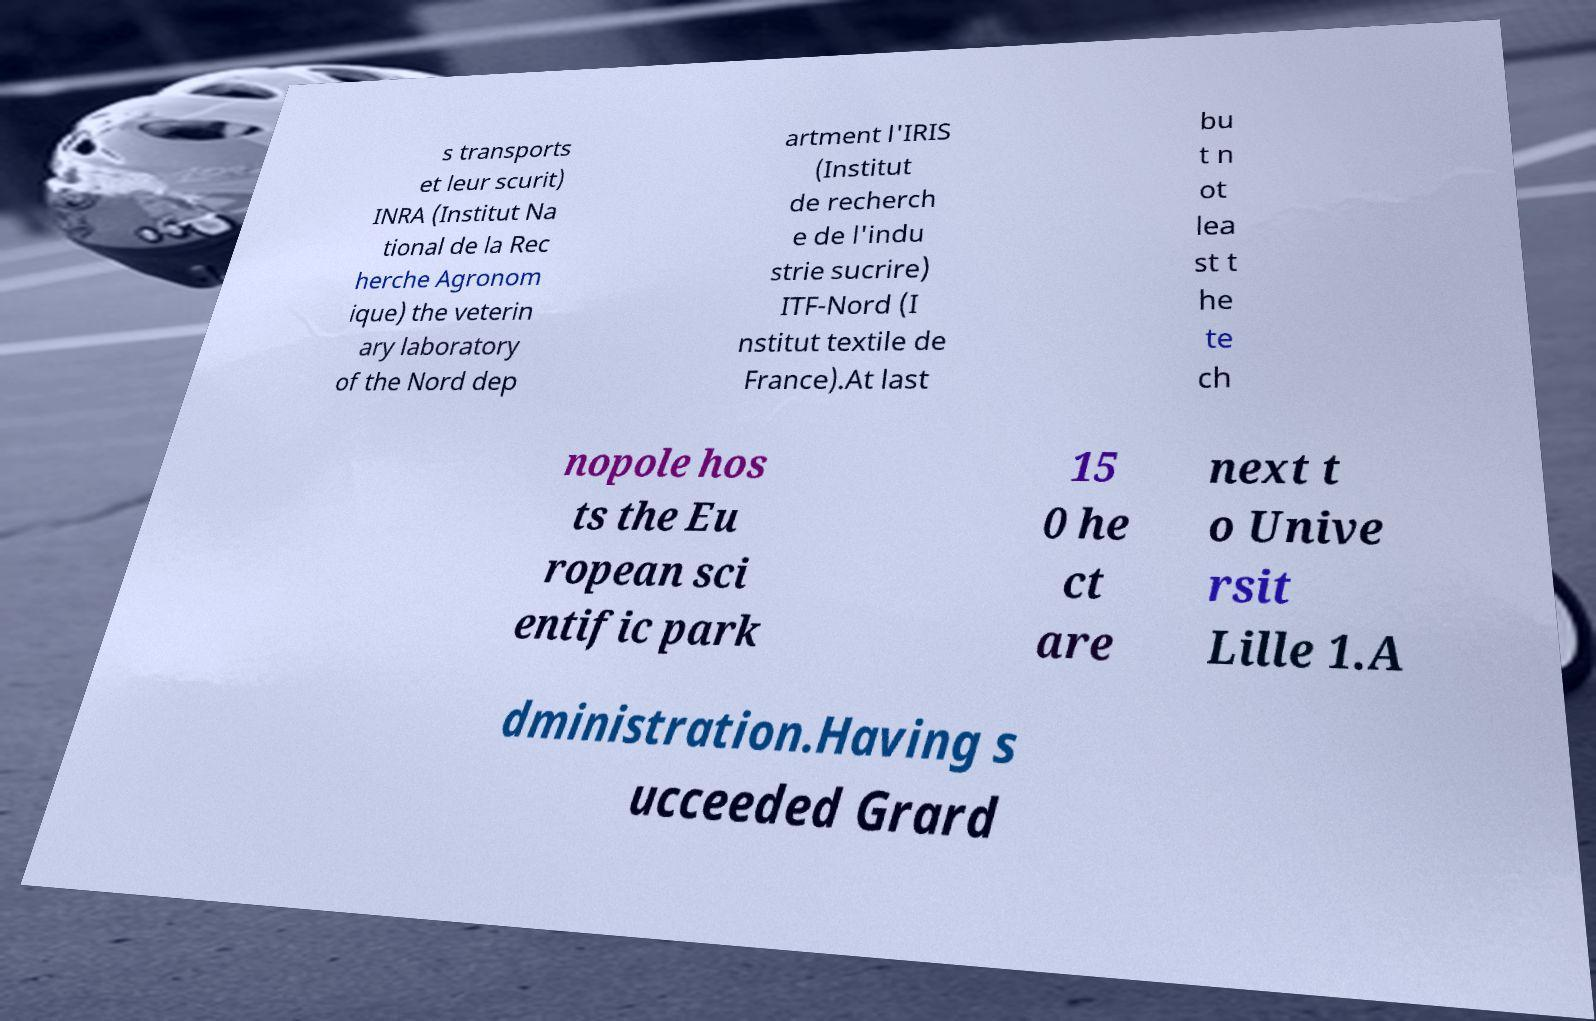Please read and relay the text visible in this image. What does it say? s transports et leur scurit) INRA (Institut Na tional de la Rec herche Agronom ique) the veterin ary laboratory of the Nord dep artment l'IRIS (Institut de recherch e de l'indu strie sucrire) ITF-Nord (I nstitut textile de France).At last bu t n ot lea st t he te ch nopole hos ts the Eu ropean sci entific park 15 0 he ct are next t o Unive rsit Lille 1.A dministration.Having s ucceeded Grard 